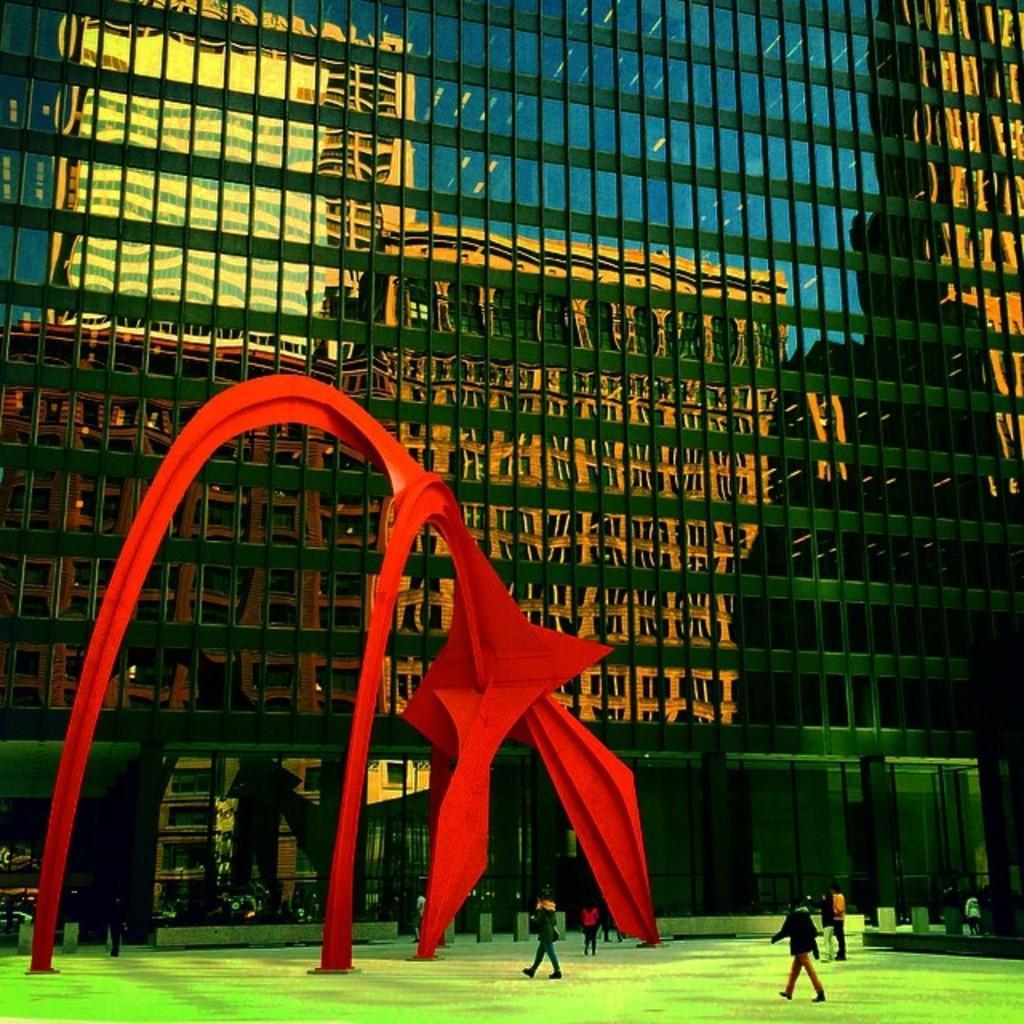Can you describe this image briefly? In this image I can see group of people, some are standing and some are walking. In front I can see the object in red color. In the background I can see the glass building. 